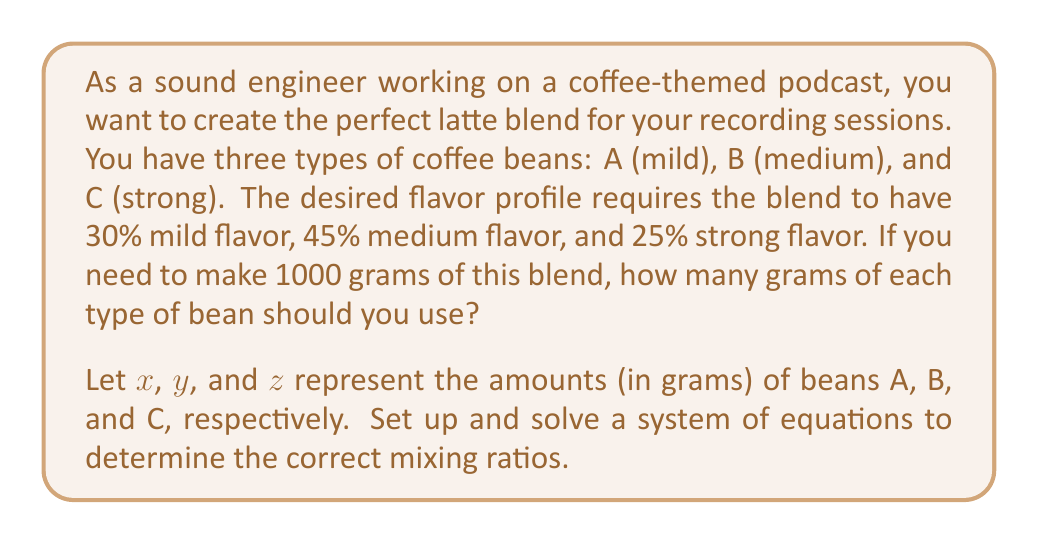Can you answer this question? Let's approach this step-by-step:

1) First, we need to set up our system of equations based on the given information:

   Equation 1: Total amount of blend
   $$x + y + z = 1000$$

   Equation 2: Mild flavor requirement (30%)
   $$\frac{x}{1000} = 0.30$$

   Equation 3: Medium flavor requirement (45%)
   $$\frac{y}{1000} = 0.45$$

2) From Equation 2:
   $$x = 1000 \cdot 0.30 = 300$$

3) From Equation 3:
   $$y = 1000 \cdot 0.45 = 450$$

4) Now we can substitute these values into Equation 1:
   $$300 + 450 + z = 1000$$

5) Solve for z:
   $$z = 1000 - 300 - 450 = 250$$

6) Verify that the percentages add up to 100%:
   $$\frac{300}{1000} + \frac{450}{1000} + \frac{250}{1000} = 0.30 + 0.45 + 0.25 = 1.00$$

Therefore, we need 300g of bean A, 450g of bean B, and 250g of bean C to achieve the desired flavor profile.
Answer: Bean A (mild): 300 grams
Bean B (medium): 450 grams
Bean C (strong): 250 grams 